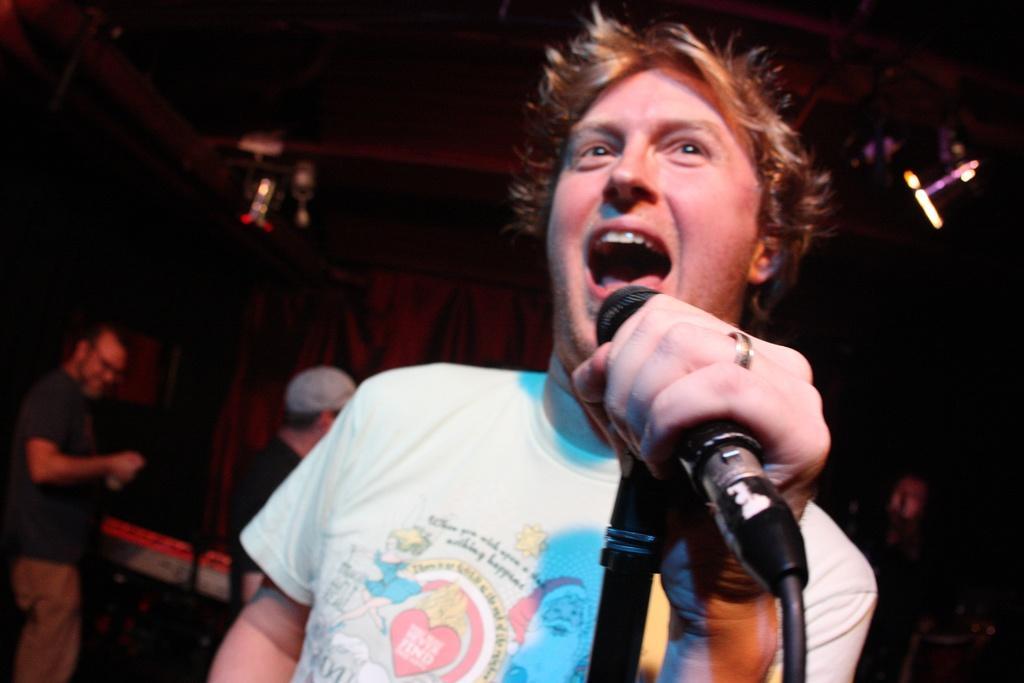In one or two sentences, can you explain what this image depicts? In the club a man is singing a song, behind him there are two persons standing, to his right side there are few lights to the roof ,in the background there is a curtain. 